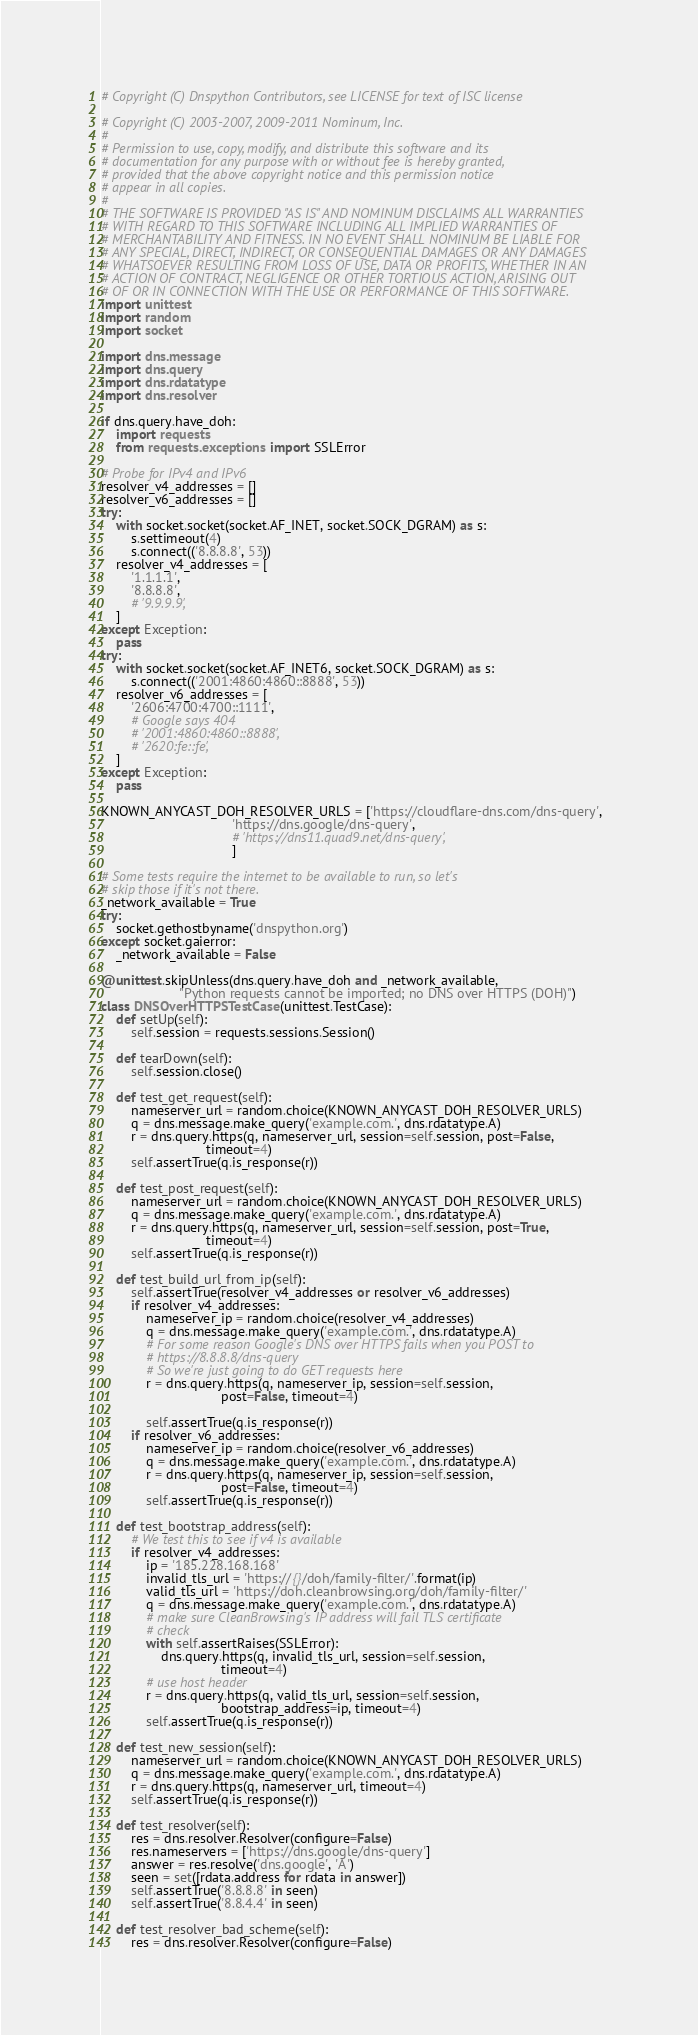Convert code to text. <code><loc_0><loc_0><loc_500><loc_500><_Python_># Copyright (C) Dnspython Contributors, see LICENSE for text of ISC license

# Copyright (C) 2003-2007, 2009-2011 Nominum, Inc.
#
# Permission to use, copy, modify, and distribute this software and its
# documentation for any purpose with or without fee is hereby granted,
# provided that the above copyright notice and this permission notice
# appear in all copies.
#
# THE SOFTWARE IS PROVIDED "AS IS" AND NOMINUM DISCLAIMS ALL WARRANTIES
# WITH REGARD TO THIS SOFTWARE INCLUDING ALL IMPLIED WARRANTIES OF
# MERCHANTABILITY AND FITNESS. IN NO EVENT SHALL NOMINUM BE LIABLE FOR
# ANY SPECIAL, DIRECT, INDIRECT, OR CONSEQUENTIAL DAMAGES OR ANY DAMAGES
# WHATSOEVER RESULTING FROM LOSS OF USE, DATA OR PROFITS, WHETHER IN AN
# ACTION OF CONTRACT, NEGLIGENCE OR OTHER TORTIOUS ACTION, ARISING OUT
# OF OR IN CONNECTION WITH THE USE OR PERFORMANCE OF THIS SOFTWARE.
import unittest
import random
import socket

import dns.message
import dns.query
import dns.rdatatype
import dns.resolver

if dns.query.have_doh:
    import requests
    from requests.exceptions import SSLError

# Probe for IPv4 and IPv6
resolver_v4_addresses = []
resolver_v6_addresses = []
try:
    with socket.socket(socket.AF_INET, socket.SOCK_DGRAM) as s:
        s.settimeout(4)
        s.connect(('8.8.8.8', 53))
    resolver_v4_addresses = [
        '1.1.1.1',
        '8.8.8.8',
        # '9.9.9.9',
    ]
except Exception:
    pass
try:
    with socket.socket(socket.AF_INET6, socket.SOCK_DGRAM) as s:
        s.connect(('2001:4860:4860::8888', 53))
    resolver_v6_addresses = [
        '2606:4700:4700::1111',
        # Google says 404
        # '2001:4860:4860::8888',
        # '2620:fe::fe',
    ]
except Exception:
    pass

KNOWN_ANYCAST_DOH_RESOLVER_URLS = ['https://cloudflare-dns.com/dns-query',
                                   'https://dns.google/dns-query',
                                   # 'https://dns11.quad9.net/dns-query',
                                   ]

# Some tests require the internet to be available to run, so let's
# skip those if it's not there.
_network_available = True
try:
    socket.gethostbyname('dnspython.org')
except socket.gaierror:
    _network_available = False

@unittest.skipUnless(dns.query.have_doh and _network_available,
                     "Python requests cannot be imported; no DNS over HTTPS (DOH)")
class DNSOverHTTPSTestCase(unittest.TestCase):
    def setUp(self):
        self.session = requests.sessions.Session()

    def tearDown(self):
        self.session.close()

    def test_get_request(self):
        nameserver_url = random.choice(KNOWN_ANYCAST_DOH_RESOLVER_URLS)
        q = dns.message.make_query('example.com.', dns.rdatatype.A)
        r = dns.query.https(q, nameserver_url, session=self.session, post=False,
                            timeout=4)
        self.assertTrue(q.is_response(r))

    def test_post_request(self):
        nameserver_url = random.choice(KNOWN_ANYCAST_DOH_RESOLVER_URLS)
        q = dns.message.make_query('example.com.', dns.rdatatype.A)
        r = dns.query.https(q, nameserver_url, session=self.session, post=True,
                            timeout=4)
        self.assertTrue(q.is_response(r))

    def test_build_url_from_ip(self):
        self.assertTrue(resolver_v4_addresses or resolver_v6_addresses)
        if resolver_v4_addresses:
            nameserver_ip = random.choice(resolver_v4_addresses)
            q = dns.message.make_query('example.com.', dns.rdatatype.A)
            # For some reason Google's DNS over HTTPS fails when you POST to
            # https://8.8.8.8/dns-query
            # So we're just going to do GET requests here
            r = dns.query.https(q, nameserver_ip, session=self.session,
                                post=False, timeout=4)

            self.assertTrue(q.is_response(r))
        if resolver_v6_addresses:
            nameserver_ip = random.choice(resolver_v6_addresses)
            q = dns.message.make_query('example.com.', dns.rdatatype.A)
            r = dns.query.https(q, nameserver_ip, session=self.session,
                                post=False, timeout=4)
            self.assertTrue(q.is_response(r))

    def test_bootstrap_address(self):
        # We test this to see if v4 is available
        if resolver_v4_addresses:
            ip = '185.228.168.168'
            invalid_tls_url = 'https://{}/doh/family-filter/'.format(ip)
            valid_tls_url = 'https://doh.cleanbrowsing.org/doh/family-filter/'
            q = dns.message.make_query('example.com.', dns.rdatatype.A)
            # make sure CleanBrowsing's IP address will fail TLS certificate
            # check
            with self.assertRaises(SSLError):
                dns.query.https(q, invalid_tls_url, session=self.session,
                                timeout=4)
            # use host header
            r = dns.query.https(q, valid_tls_url, session=self.session,
                                bootstrap_address=ip, timeout=4)
            self.assertTrue(q.is_response(r))

    def test_new_session(self):
        nameserver_url = random.choice(KNOWN_ANYCAST_DOH_RESOLVER_URLS)
        q = dns.message.make_query('example.com.', dns.rdatatype.A)
        r = dns.query.https(q, nameserver_url, timeout=4)
        self.assertTrue(q.is_response(r))

    def test_resolver(self):
        res = dns.resolver.Resolver(configure=False)
        res.nameservers = ['https://dns.google/dns-query']
        answer = res.resolve('dns.google', 'A')
        seen = set([rdata.address for rdata in answer])
        self.assertTrue('8.8.8.8' in seen)
        self.assertTrue('8.8.4.4' in seen)

    def test_resolver_bad_scheme(self):
        res = dns.resolver.Resolver(configure=False)</code> 